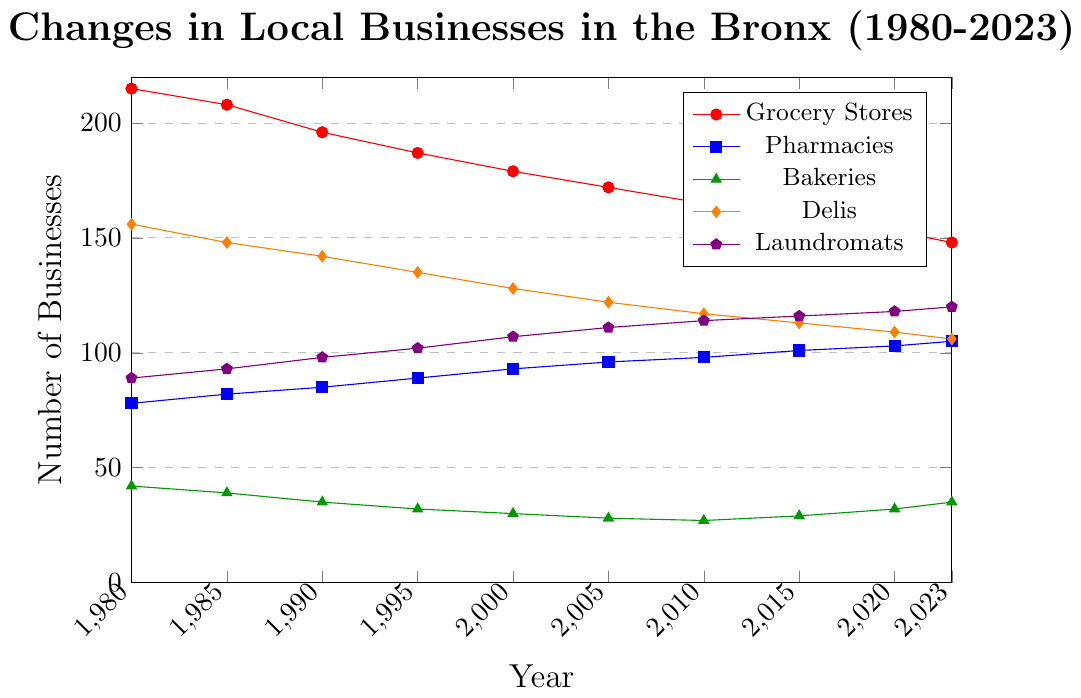How many grocery stores were there in 1980 and 2023? How many did they reduce by? To find the number of grocery stores in 1980 and 2023, refer to the plot lines corresponding to these years. The number of grocery stores in 1980 is 215, and in 2023, it's 148. The reduction can be calculated as 215 - 148.
Answer: 67 Which category has shown a consistent increase in the number of businesses from 1980 to 2023? Observe each plot line for a consistent upward trend from 1980 to 2023. Pharmacies and laundromats show a consistent increase.
Answer: Pharmacies, Laundromats Between which years did grocery stores see the most significant decline? Look at the slope of the red line (grocery stores) to identify steep declines. The steepest decline appears between 1980 and 1990, with the number dropping from 215 to 196, then further dropping till 1995.
Answer: 1980 to 1995 In what year did bakeries show the lowest number of businesses, and what was the value? Find the lowest point on the green line (bakeries). The lowest number of bakeries is 27, observed in 2010.
Answer: 2010, 27 Which category had the highest number of businesses in 2000? Refer to the plot for the year 2000 and compare the highest values among all categories. Grocery stores had the highest number in 2000 with 179 businesses.
Answer: Grocery Stores What pattern do delis show from 1980 to 2023? Analyze the line for delis (orange) and describe the trend. The number of delis has decreased steadily over time.
Answer: Decreasing Are there any categories that increased and then decreased from 2010 to 2023? Compare lines for each category from 2010 to 2023 for any increase followed by a decrease. Bakeries increased from 27 in 2010 to 29 in 2015, and then to 35 in 2023, so they do not fit the pattern. It appears no category shows an increase followed by a decrease in this period.
Answer: No Compare the number of laundromats in 2005 and 2023. Refer to the plot lines for laundromats for the years 2005 and 2023 and compare the numbers. Laundromats increased from 111 in 2005 to 120 in 2023.
Answer: 2005:111, 2023:120, Increased by 9 